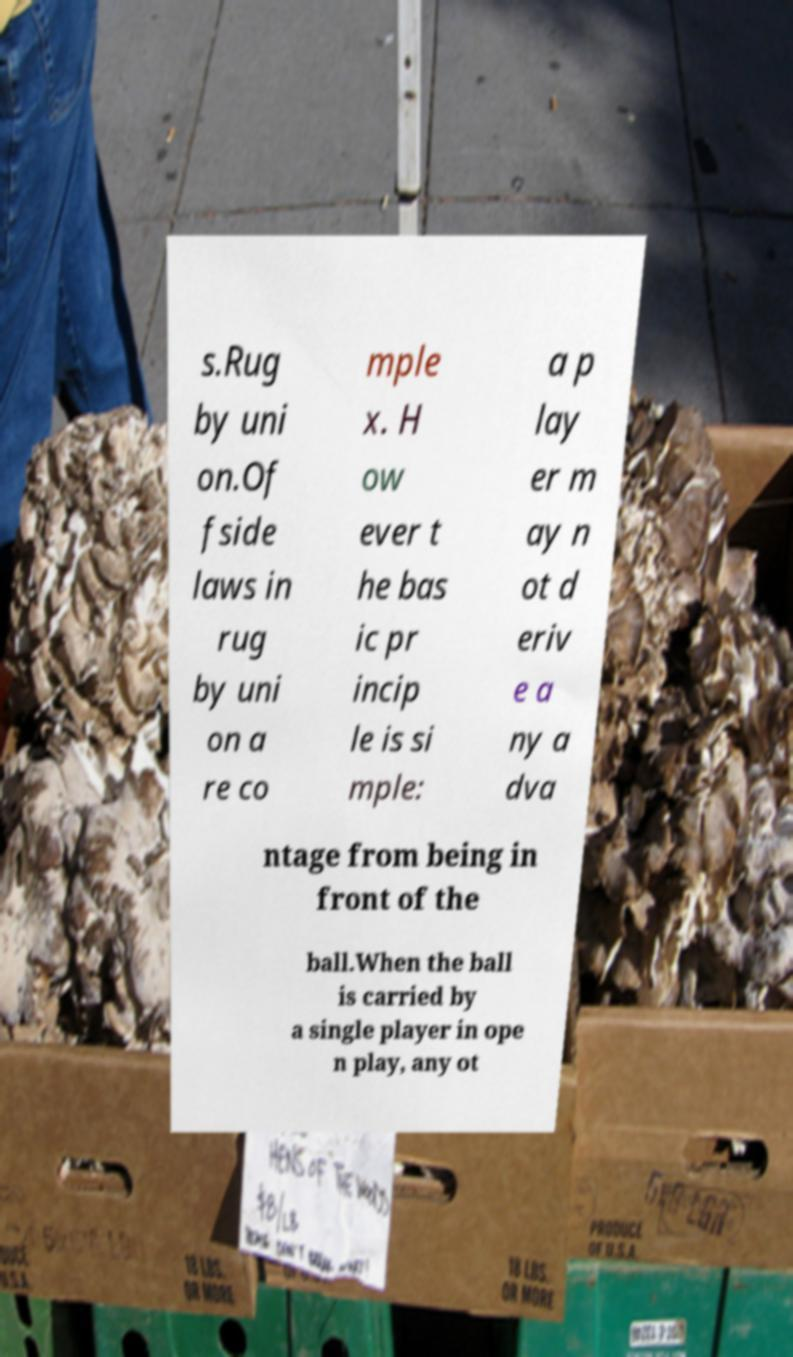For documentation purposes, I need the text within this image transcribed. Could you provide that? s.Rug by uni on.Of fside laws in rug by uni on a re co mple x. H ow ever t he bas ic pr incip le is si mple: a p lay er m ay n ot d eriv e a ny a dva ntage from being in front of the ball.When the ball is carried by a single player in ope n play, any ot 